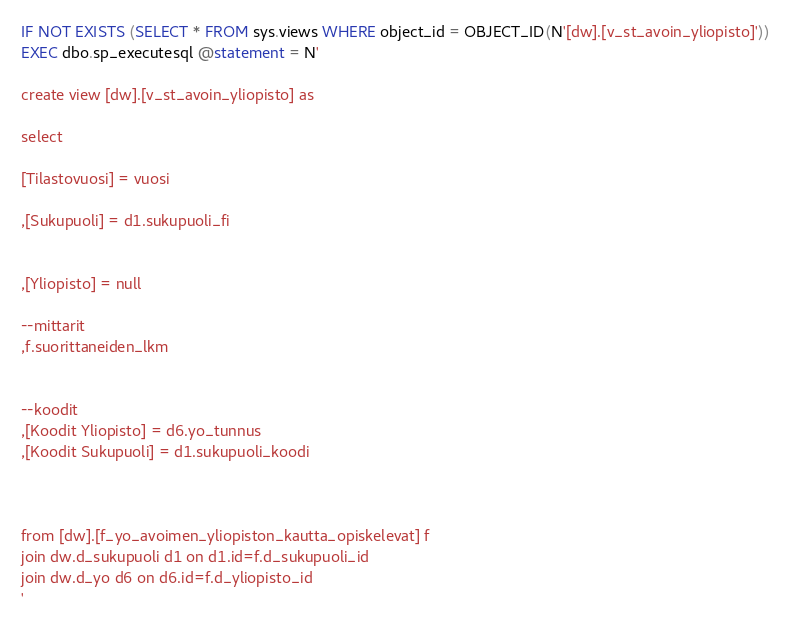Convert code to text. <code><loc_0><loc_0><loc_500><loc_500><_SQL_>

IF NOT EXISTS (SELECT * FROM sys.views WHERE object_id = OBJECT_ID(N'[dw].[v_st_avoin_yliopisto]'))
EXEC dbo.sp_executesql @statement = N'

create view [dw].[v_st_avoin_yliopisto] as

select 

[Tilastovuosi] = vuosi

,[Sukupuoli] = d1.sukupuoli_fi


,[Yliopisto] = null

--mittarit
,f.suorittaneiden_lkm


--koodit
,[Koodit Yliopisto] = d6.yo_tunnus
,[Koodit Sukupuoli] = d1.sukupuoli_koodi



from [dw].[f_yo_avoimen_yliopiston_kautta_opiskelevat] f
join dw.d_sukupuoli d1 on d1.id=f.d_sukupuoli_id
join dw.d_yo d6 on d6.id=f.d_yliopisto_id
'</code> 